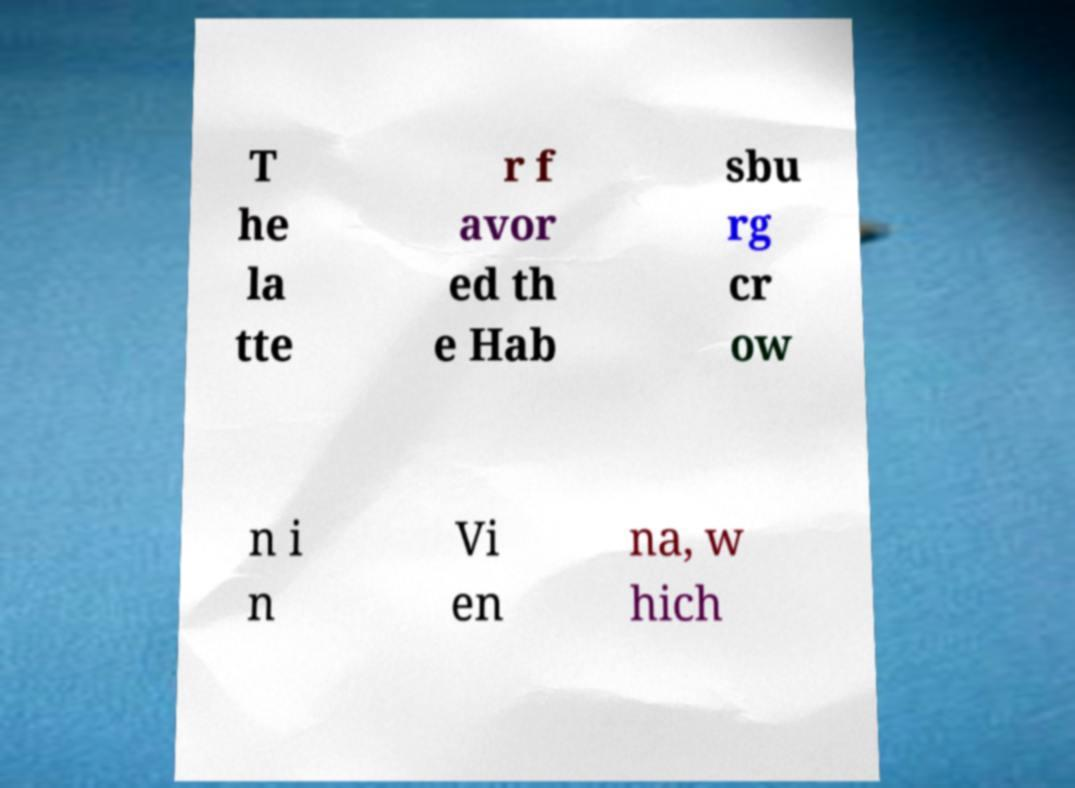I need the written content from this picture converted into text. Can you do that? T he la tte r f avor ed th e Hab sbu rg cr ow n i n Vi en na, w hich 